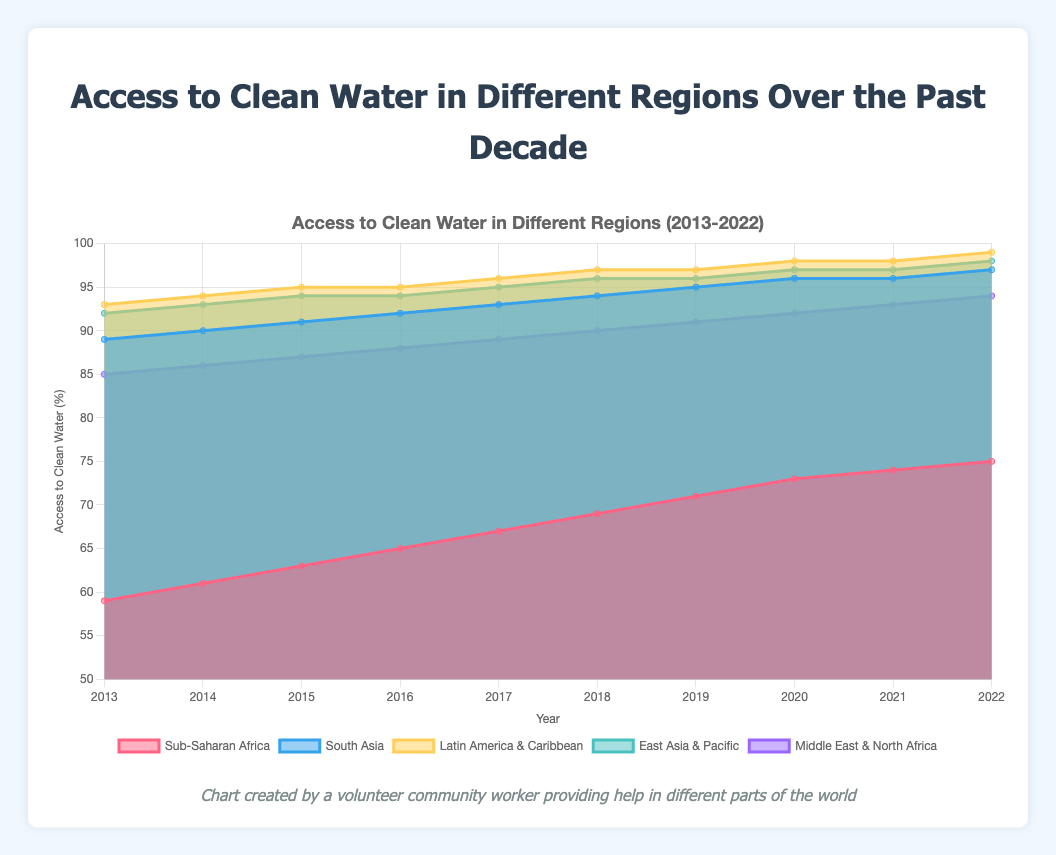What is the overall trend of access to clean water in Sub-Saharan Africa from 2013 to 2022? First, look at the data points of Sub-Saharan Africa from 2013 to 2022 in the chart. The access percentage steadily increases from 59% in 2013 to 75% in 2022.
Answer: Increasing trend Which region had the highest access to clean water in 2022? Observe the data points for all regions in the year 2022 on the chart. The Latin America & Caribbean region had the highest access at 99%.
Answer: Latin America & Caribbean In which year did South Asia reach a 95% access to clean water? Identify the access values for South Asia across the years. The chart shows South Asia reached 95% access in 2019.
Answer: 2019 By how much did the access to clean water in the Middle East & North Africa improve from 2013 to 2022? Look at the access percentages for the Middle East & North Africa in 2013 and 2022. It improved from 85% to 94%, resulting in an improvement of 94% - 85% = 9%.
Answer: 9% Which region showed the least improvement in access to clean water over the decade? Calculate the difference between the starting and ending values for each region and compare them. Sub-Saharan Africa improved by 16% (75% - 59%), the least among all regions.
Answer: Sub-Saharan Africa Which two regions had a constant increase in access to clean water every year without any drop? Examine the trends for all regions year by year. South Asia (from 89% to 97%) and Sub-Saharan Africa (from 59% to 75%) showed a constant increase without any drops.
Answer: South Asia and Sub-Saharan Africa What was the average access to clean water in East Asia & Pacific across the decade? Sum the access percentages for East Asia & Pacific from 2013 to 2022 and divide by 10. The values are [92, 93, 94, 94, 95, 96, 96, 97, 97, 98], with a sum of 952. Hence, the average is 952/10 = 95.2%.
Answer: 95.2% Which region's access to clean water has caught up more with East Asia & Pacific over the years? Compare the relative improvements of all regions to the initial lead of East Asia & Pacific. Latin America & Caribbean almost matched East Asia & Pacific by reaching 99% in 2022.
Answer: Latin America & Caribbean Is there any region with more than 90% access to clean water throughout the decade? Check the minimum access percentage for each region throughout the decade. Only East Asia & Pacific consistently had more than 90% from 2013 to 2022.
Answer: East Asia & Pacific What is the combined access percentage average for all regions in 2022? Sum the access percentages for all regions in 2022 and divide by the number of regions (5). The values are [75, 97, 99, 98, 94], with a sum of 463. Hence, the combined average is 463/5 = 92.6%.
Answer: 92.6% 